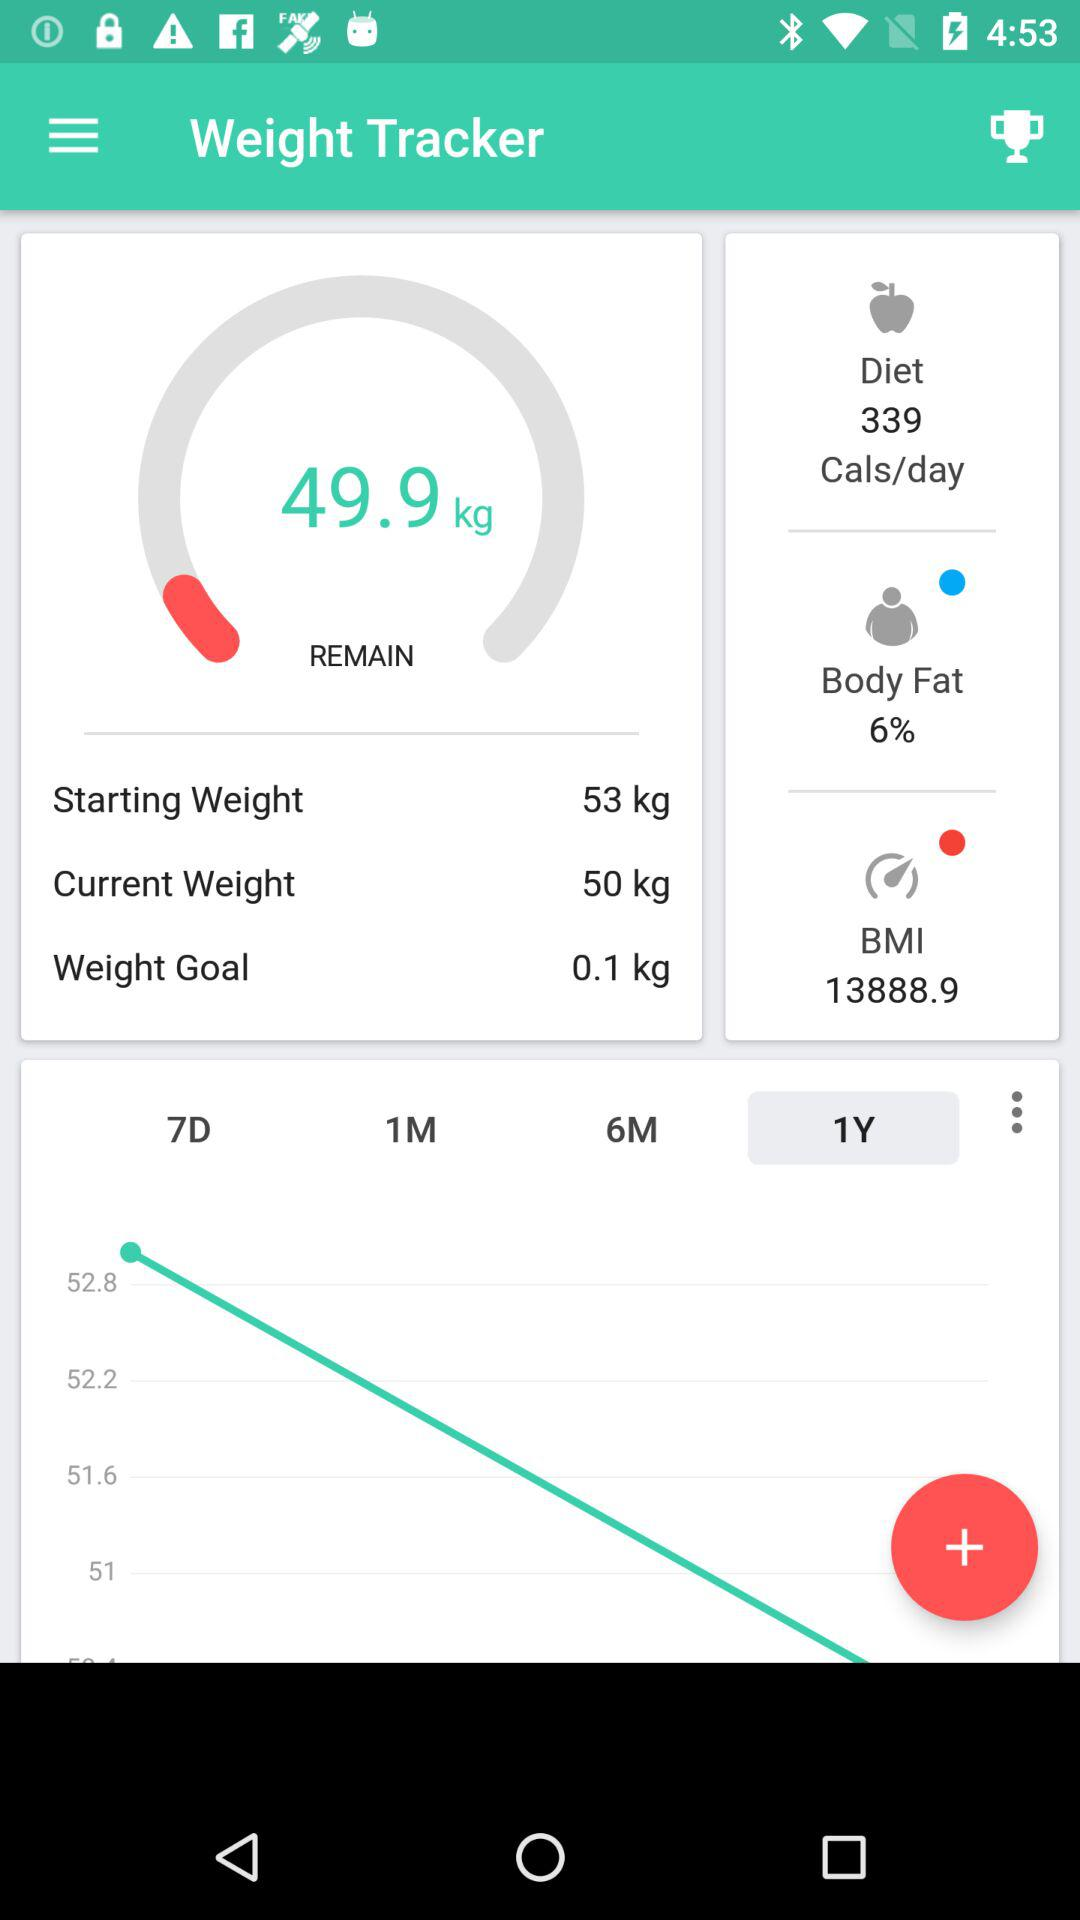How much is the body fat percentage? The body fat percentage is 6. 